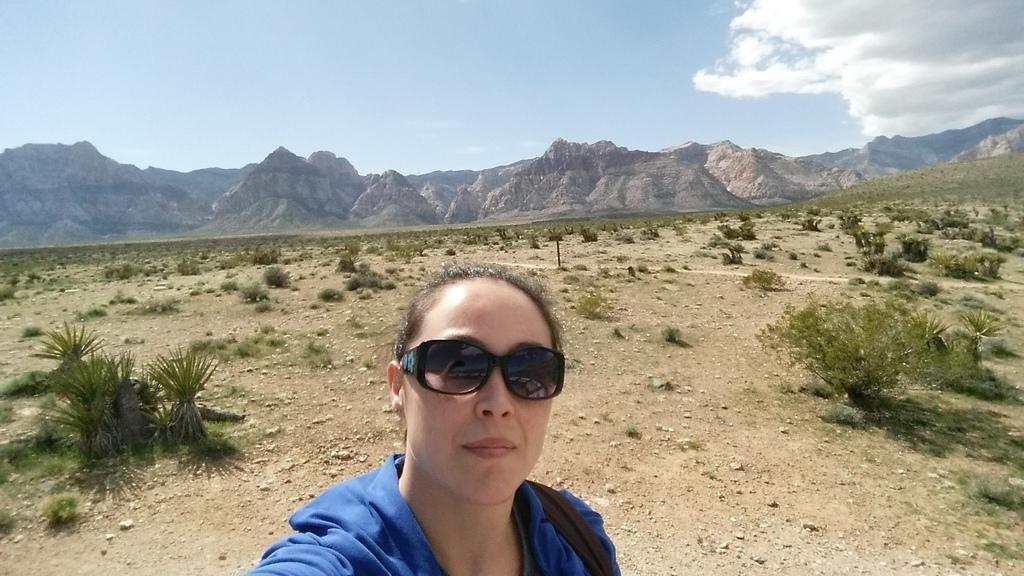Please provide a concise description of this image. In this image we can see a woman wearing the goggles, there are some plants, mountains and stones on the ground, in the background we can see the sky with clouds. 